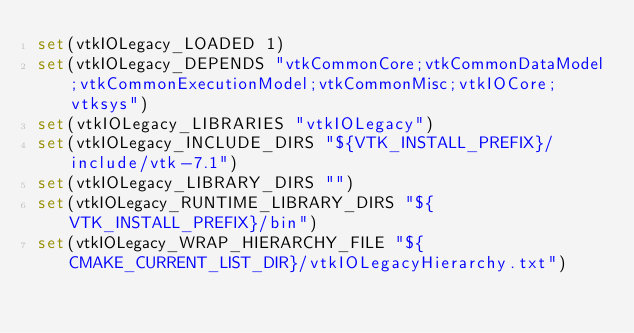<code> <loc_0><loc_0><loc_500><loc_500><_CMake_>set(vtkIOLegacy_LOADED 1)
set(vtkIOLegacy_DEPENDS "vtkCommonCore;vtkCommonDataModel;vtkCommonExecutionModel;vtkCommonMisc;vtkIOCore;vtksys")
set(vtkIOLegacy_LIBRARIES "vtkIOLegacy")
set(vtkIOLegacy_INCLUDE_DIRS "${VTK_INSTALL_PREFIX}/include/vtk-7.1")
set(vtkIOLegacy_LIBRARY_DIRS "")
set(vtkIOLegacy_RUNTIME_LIBRARY_DIRS "${VTK_INSTALL_PREFIX}/bin")
set(vtkIOLegacy_WRAP_HIERARCHY_FILE "${CMAKE_CURRENT_LIST_DIR}/vtkIOLegacyHierarchy.txt")</code> 